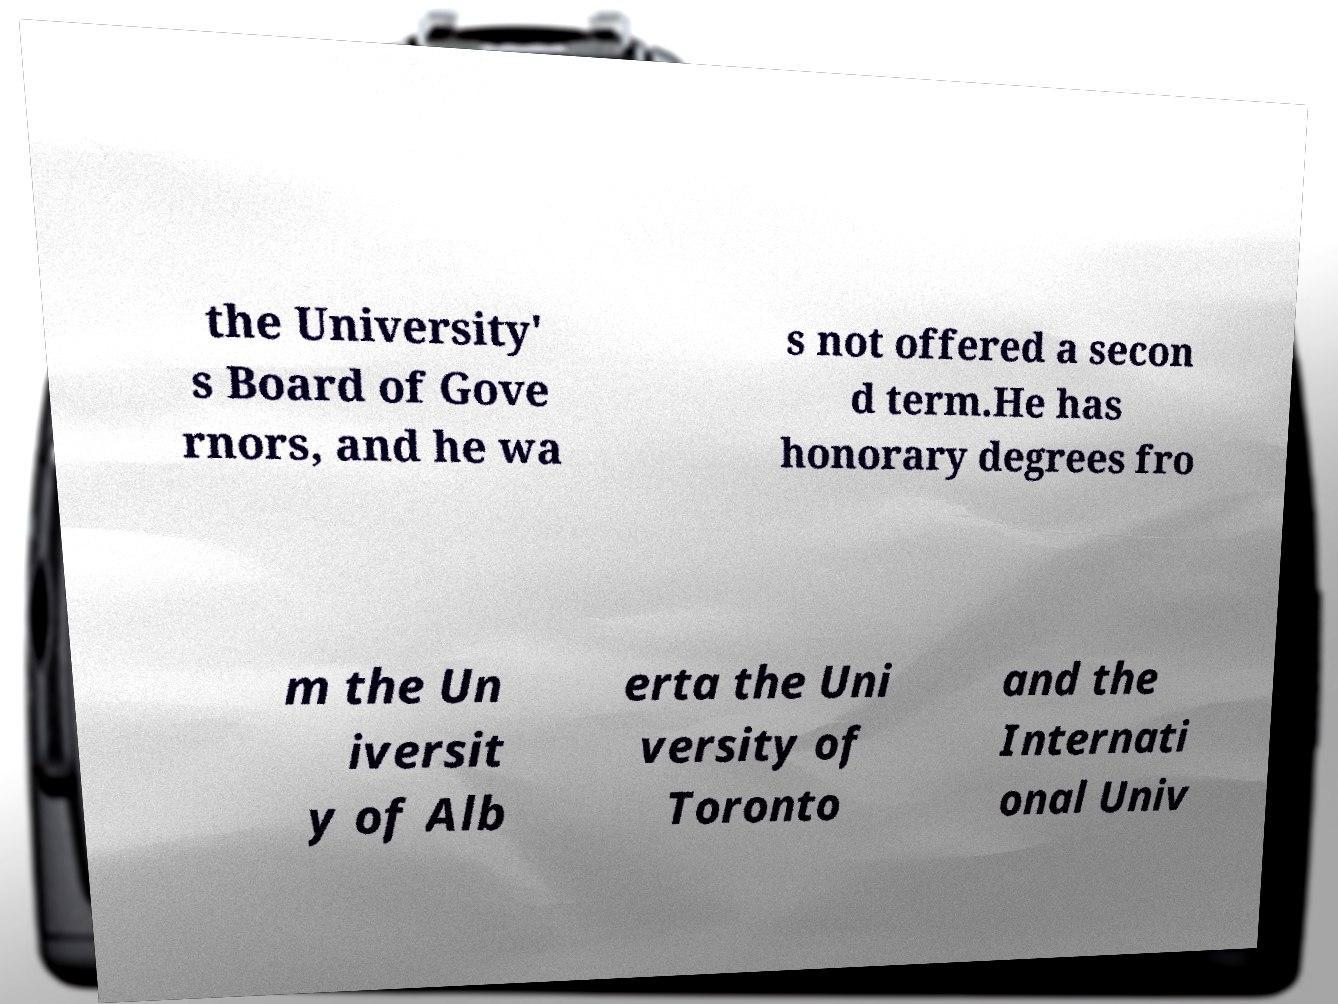What messages or text are displayed in this image? I need them in a readable, typed format. the University' s Board of Gove rnors, and he wa s not offered a secon d term.He has honorary degrees fro m the Un iversit y of Alb erta the Uni versity of Toronto and the Internati onal Univ 